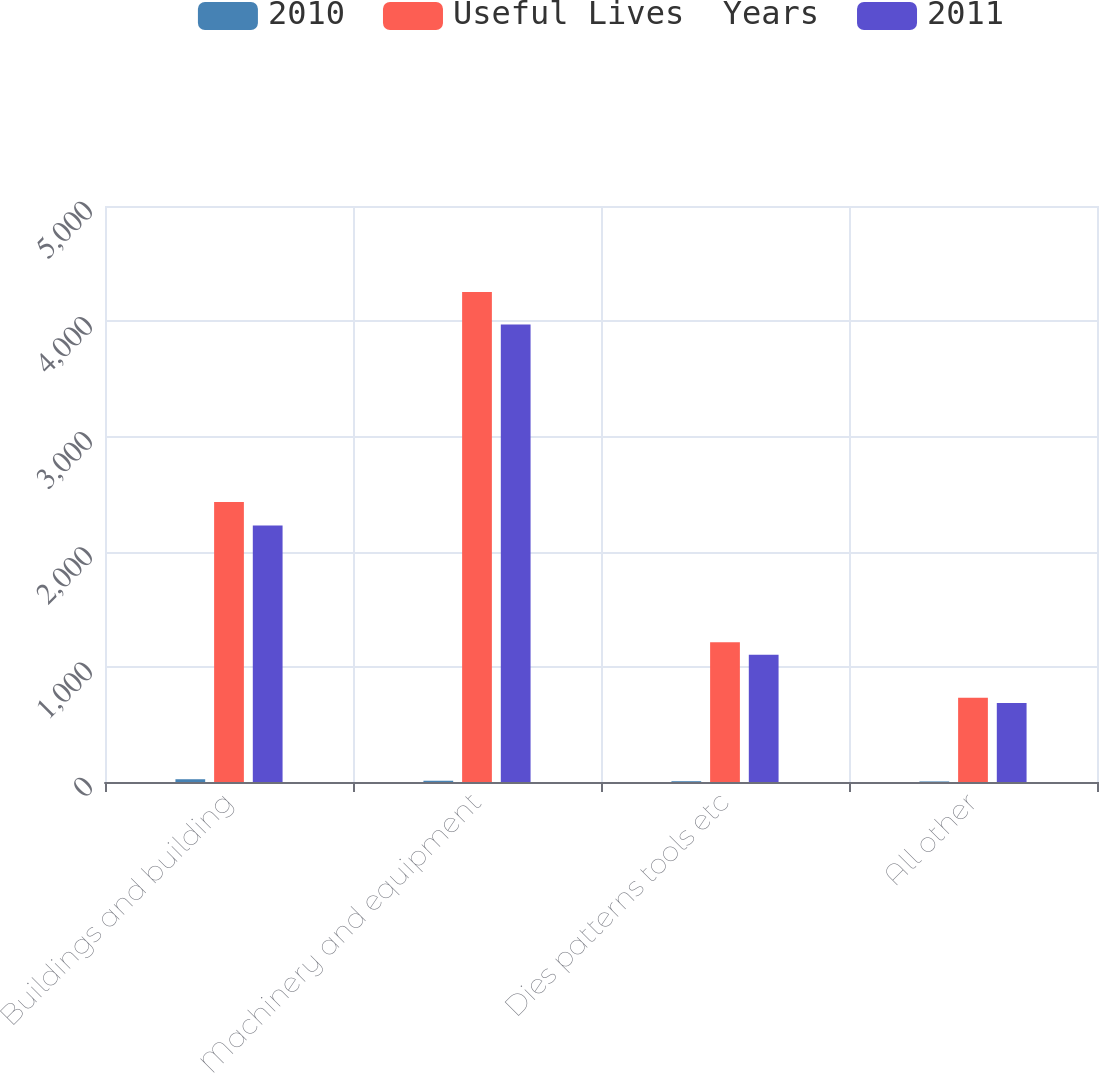<chart> <loc_0><loc_0><loc_500><loc_500><stacked_bar_chart><ecel><fcel>Buildings and building<fcel>Machinery and equipment<fcel>Dies patterns tools etc<fcel>All other<nl><fcel>2010<fcel>24<fcel>11<fcel>7<fcel>5<nl><fcel>Useful Lives  Years<fcel>2430<fcel>4254<fcel>1213<fcel>731<nl><fcel>2011<fcel>2226<fcel>3972<fcel>1105<fcel>685<nl></chart> 